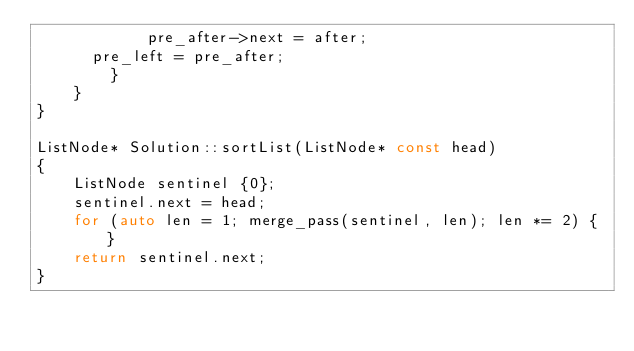<code> <loc_0><loc_0><loc_500><loc_500><_C++_>            pre_after->next = after;
			pre_left = pre_after;
        }
    }
}

ListNode* Solution::sortList(ListNode* const head)
{
    ListNode sentinel {0};
    sentinel.next = head;
    for (auto len = 1; merge_pass(sentinel, len); len *= 2) { }
    return sentinel.next;
}
</code> 